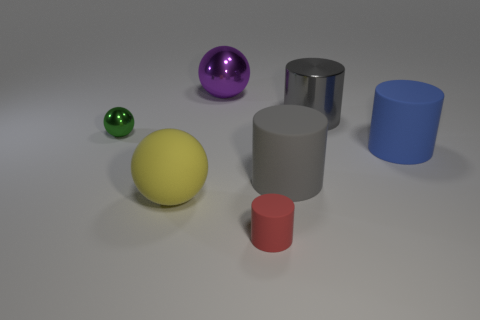Subtract all brown spheres. How many gray cylinders are left? 2 Subtract all blue cylinders. How many cylinders are left? 3 Subtract all brown cylinders. Subtract all green blocks. How many cylinders are left? 4 Add 1 tiny gray rubber things. How many objects exist? 8 Subtract all balls. How many objects are left? 4 Subtract 0 brown cylinders. How many objects are left? 7 Subtract all red cylinders. Subtract all tiny rubber things. How many objects are left? 5 Add 4 small green metallic things. How many small green metallic things are left? 5 Add 6 large green shiny cylinders. How many large green shiny cylinders exist? 6 